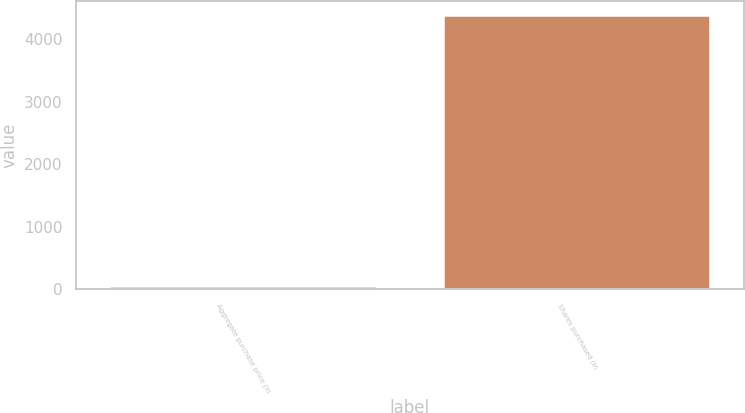Convert chart. <chart><loc_0><loc_0><loc_500><loc_500><bar_chart><fcel>Aggregate purchase price (in<fcel>Shares purchased (in<nl><fcel>51<fcel>4385<nl></chart> 